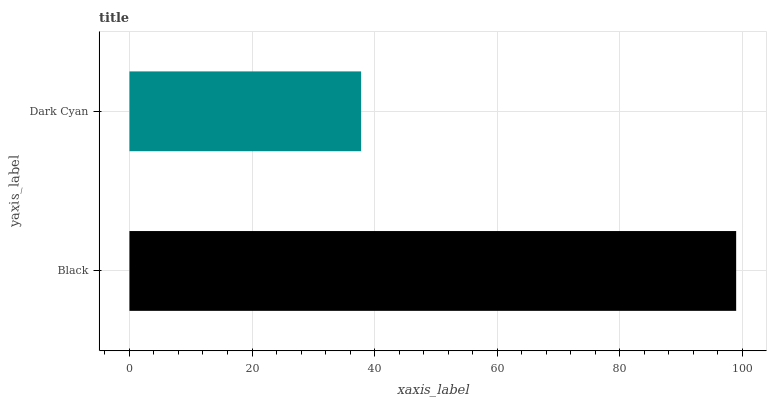Is Dark Cyan the minimum?
Answer yes or no. Yes. Is Black the maximum?
Answer yes or no. Yes. Is Dark Cyan the maximum?
Answer yes or no. No. Is Black greater than Dark Cyan?
Answer yes or no. Yes. Is Dark Cyan less than Black?
Answer yes or no. Yes. Is Dark Cyan greater than Black?
Answer yes or no. No. Is Black less than Dark Cyan?
Answer yes or no. No. Is Black the high median?
Answer yes or no. Yes. Is Dark Cyan the low median?
Answer yes or no. Yes. Is Dark Cyan the high median?
Answer yes or no. No. Is Black the low median?
Answer yes or no. No. 